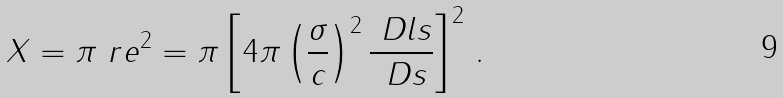Convert formula to latex. <formula><loc_0><loc_0><loc_500><loc_500>X = \pi \ r e ^ { 2 } = \pi \left [ 4 \pi \left ( \frac { \sigma } { c } \right ) ^ { 2 } \frac { \ D l s } { \ D s } \right ] ^ { 2 } \, .</formula> 